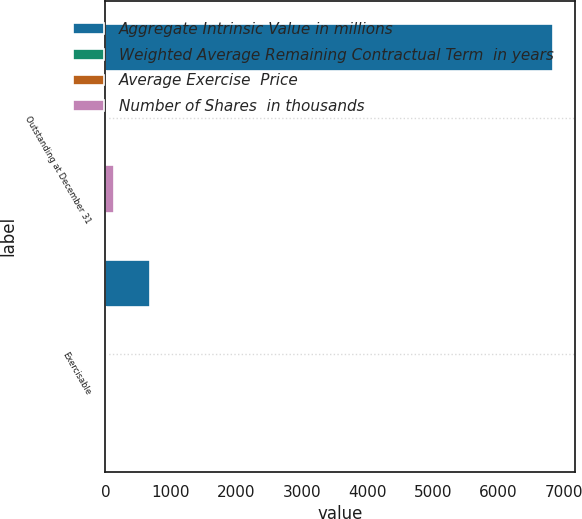Convert chart to OTSL. <chart><loc_0><loc_0><loc_500><loc_500><stacked_bar_chart><ecel><fcel>Outstanding at December 31<fcel>Exercisable<nl><fcel>Aggregate Intrinsic Value in millions<fcel>6838<fcel>679<nl><fcel>Weighted Average Remaining Contractual Term  in years<fcel>9.5<fcel>6.42<nl><fcel>Average Exercise  Price<fcel>5.58<fcel>4.89<nl><fcel>Number of Shares  in thousands<fcel>123.4<fcel>14.4<nl></chart> 